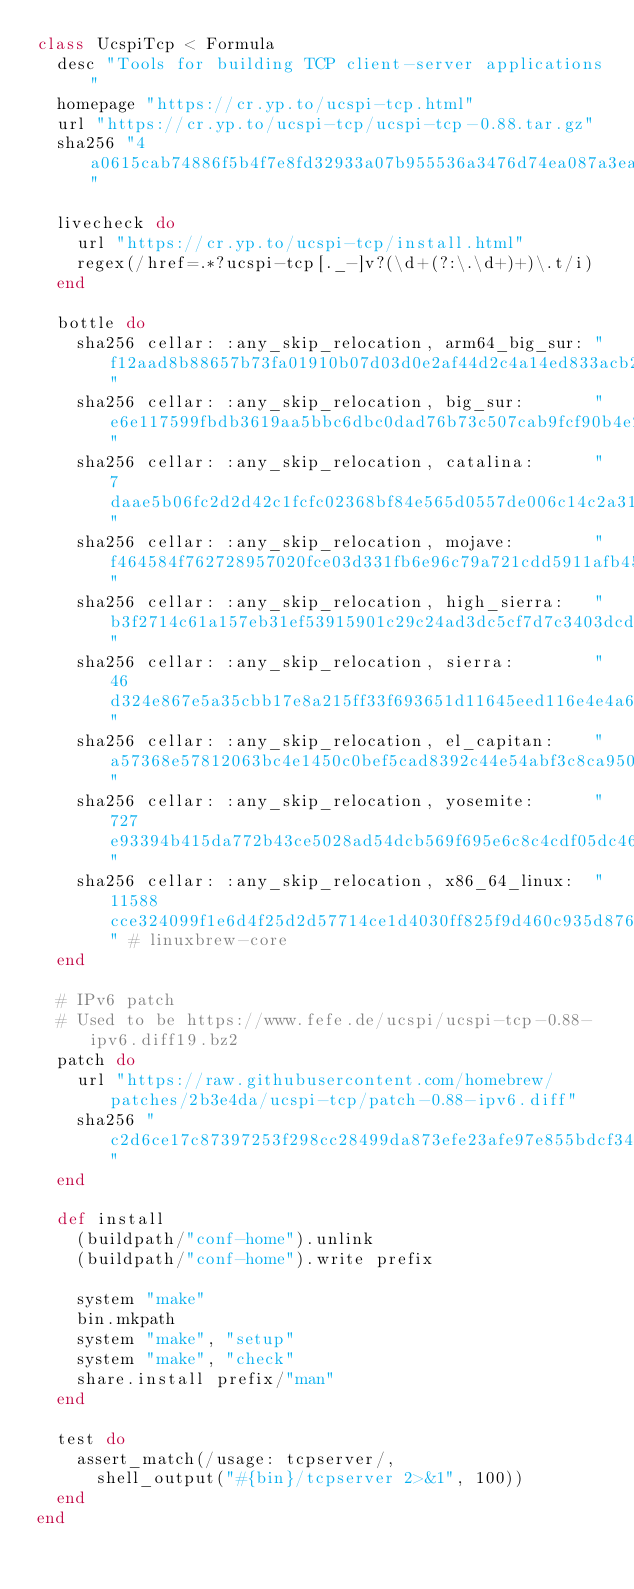<code> <loc_0><loc_0><loc_500><loc_500><_Ruby_>class UcspiTcp < Formula
  desc "Tools for building TCP client-server applications"
  homepage "https://cr.yp.to/ucspi-tcp.html"
  url "https://cr.yp.to/ucspi-tcp/ucspi-tcp-0.88.tar.gz"
  sha256 "4a0615cab74886f5b4f7e8fd32933a07b955536a3476d74ea087a3ea66a23e9c"

  livecheck do
    url "https://cr.yp.to/ucspi-tcp/install.html"
    regex(/href=.*?ucspi-tcp[._-]v?(\d+(?:\.\d+)+)\.t/i)
  end

  bottle do
    sha256 cellar: :any_skip_relocation, arm64_big_sur: "f12aad8b88657b73fa01910b07d03d0e2af44d2c4a14ed833acb25bfe1d55f6b"
    sha256 cellar: :any_skip_relocation, big_sur:       "e6e117599fbdb3619aa5bbc6dbc0dad76b73c507cab9fcf90b4e258b3a3ffb9f"
    sha256 cellar: :any_skip_relocation, catalina:      "7daae5b06fc2d2d42c1fcfc02368bf84e565d0557de006c14c2a31cc91cd25ee"
    sha256 cellar: :any_skip_relocation, mojave:        "f464584f762728957020fce03d331fb6e96c79a721cdd5911afb452d4b91da7b"
    sha256 cellar: :any_skip_relocation, high_sierra:   "b3f2714c61a157eb31ef53915901c29c24ad3dc5cf7d7c3403dcd501399e26b4"
    sha256 cellar: :any_skip_relocation, sierra:        "46d324e867e5a35cbb17e8a215ff33f693651d11645eed116e4e4a6c02085b34"
    sha256 cellar: :any_skip_relocation, el_capitan:    "a57368e57812063bc4e1450c0bef5cad8392c44e54abf3c8ca950ea51abe7ae9"
    sha256 cellar: :any_skip_relocation, yosemite:      "727e93394b415da772b43ce5028ad54dcb569f695e6c8c4cdf05dc462b2febbe"
    sha256 cellar: :any_skip_relocation, x86_64_linux:  "11588cce324099f1e6d4f25d2d57714ce1d4030ff825f9d460c935d876801073" # linuxbrew-core
  end

  # IPv6 patch
  # Used to be https://www.fefe.de/ucspi/ucspi-tcp-0.88-ipv6.diff19.bz2
  patch do
    url "https://raw.githubusercontent.com/homebrew/patches/2b3e4da/ucspi-tcp/patch-0.88-ipv6.diff"
    sha256 "c2d6ce17c87397253f298cc28499da873efe23afe97e855bdcf34ae66374036a"
  end

  def install
    (buildpath/"conf-home").unlink
    (buildpath/"conf-home").write prefix

    system "make"
    bin.mkpath
    system "make", "setup"
    system "make", "check"
    share.install prefix/"man"
  end

  test do
    assert_match(/usage: tcpserver/,
      shell_output("#{bin}/tcpserver 2>&1", 100))
  end
end
</code> 